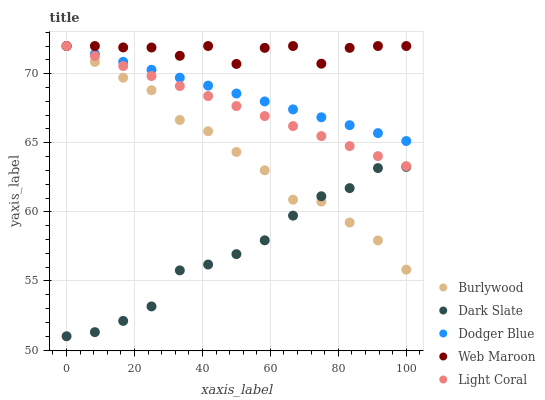Does Dark Slate have the minimum area under the curve?
Answer yes or no. Yes. Does Web Maroon have the maximum area under the curve?
Answer yes or no. Yes. Does Light Coral have the minimum area under the curve?
Answer yes or no. No. Does Light Coral have the maximum area under the curve?
Answer yes or no. No. Is Light Coral the smoothest?
Answer yes or no. Yes. Is Web Maroon the roughest?
Answer yes or no. Yes. Is Dark Slate the smoothest?
Answer yes or no. No. Is Dark Slate the roughest?
Answer yes or no. No. Does Dark Slate have the lowest value?
Answer yes or no. Yes. Does Light Coral have the lowest value?
Answer yes or no. No. Does Web Maroon have the highest value?
Answer yes or no. Yes. Does Dark Slate have the highest value?
Answer yes or no. No. Is Dark Slate less than Web Maroon?
Answer yes or no. Yes. Is Web Maroon greater than Dark Slate?
Answer yes or no. Yes. Does Burlywood intersect Dodger Blue?
Answer yes or no. Yes. Is Burlywood less than Dodger Blue?
Answer yes or no. No. Is Burlywood greater than Dodger Blue?
Answer yes or no. No. Does Dark Slate intersect Web Maroon?
Answer yes or no. No. 